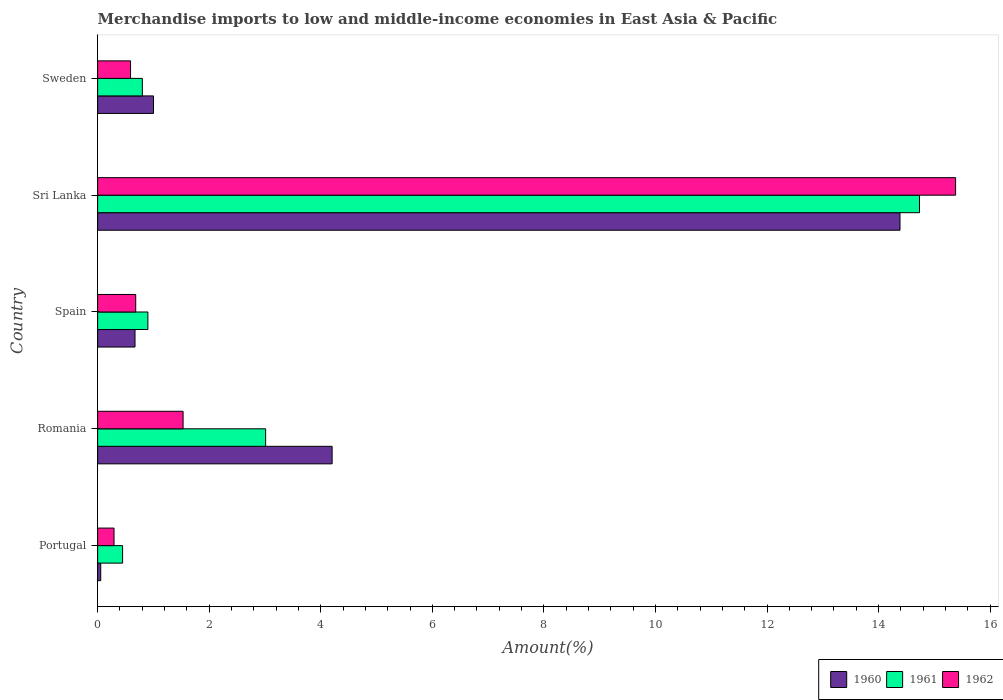How many different coloured bars are there?
Offer a terse response. 3. How many groups of bars are there?
Your answer should be compact. 5. How many bars are there on the 5th tick from the bottom?
Give a very brief answer. 3. What is the percentage of amount earned from merchandise imports in 1961 in Romania?
Offer a terse response. 3.01. Across all countries, what is the maximum percentage of amount earned from merchandise imports in 1961?
Offer a terse response. 14.73. Across all countries, what is the minimum percentage of amount earned from merchandise imports in 1961?
Provide a short and direct response. 0.45. In which country was the percentage of amount earned from merchandise imports in 1962 maximum?
Your answer should be compact. Sri Lanka. What is the total percentage of amount earned from merchandise imports in 1962 in the graph?
Ensure brevity in your answer.  18.48. What is the difference between the percentage of amount earned from merchandise imports in 1960 in Romania and that in Spain?
Provide a short and direct response. 3.53. What is the difference between the percentage of amount earned from merchandise imports in 1962 in Romania and the percentage of amount earned from merchandise imports in 1960 in Sri Lanka?
Your response must be concise. -12.85. What is the average percentage of amount earned from merchandise imports in 1960 per country?
Offer a very short reply. 4.06. What is the difference between the percentage of amount earned from merchandise imports in 1960 and percentage of amount earned from merchandise imports in 1962 in Sweden?
Offer a very short reply. 0.41. What is the ratio of the percentage of amount earned from merchandise imports in 1961 in Portugal to that in Romania?
Provide a succinct answer. 0.15. What is the difference between the highest and the second highest percentage of amount earned from merchandise imports in 1961?
Make the answer very short. 11.72. What is the difference between the highest and the lowest percentage of amount earned from merchandise imports in 1960?
Your answer should be compact. 14.33. In how many countries, is the percentage of amount earned from merchandise imports in 1960 greater than the average percentage of amount earned from merchandise imports in 1960 taken over all countries?
Provide a succinct answer. 2. Is the sum of the percentage of amount earned from merchandise imports in 1961 in Portugal and Romania greater than the maximum percentage of amount earned from merchandise imports in 1960 across all countries?
Your response must be concise. No. How many countries are there in the graph?
Your answer should be compact. 5. What is the difference between two consecutive major ticks on the X-axis?
Your answer should be very brief. 2. How many legend labels are there?
Ensure brevity in your answer.  3. How are the legend labels stacked?
Provide a succinct answer. Horizontal. What is the title of the graph?
Provide a short and direct response. Merchandise imports to low and middle-income economies in East Asia & Pacific. Does "2004" appear as one of the legend labels in the graph?
Make the answer very short. No. What is the label or title of the X-axis?
Give a very brief answer. Amount(%). What is the Amount(%) of 1960 in Portugal?
Your answer should be very brief. 0.06. What is the Amount(%) of 1961 in Portugal?
Offer a very short reply. 0.45. What is the Amount(%) in 1962 in Portugal?
Offer a terse response. 0.29. What is the Amount(%) of 1960 in Romania?
Give a very brief answer. 4.2. What is the Amount(%) of 1961 in Romania?
Offer a terse response. 3.01. What is the Amount(%) in 1962 in Romania?
Provide a short and direct response. 1.53. What is the Amount(%) of 1960 in Spain?
Your response must be concise. 0.67. What is the Amount(%) in 1961 in Spain?
Offer a very short reply. 0.9. What is the Amount(%) of 1962 in Spain?
Provide a succinct answer. 0.68. What is the Amount(%) of 1960 in Sri Lanka?
Give a very brief answer. 14.38. What is the Amount(%) of 1961 in Sri Lanka?
Your answer should be compact. 14.73. What is the Amount(%) of 1962 in Sri Lanka?
Provide a succinct answer. 15.38. What is the Amount(%) of 1960 in Sweden?
Provide a succinct answer. 1. What is the Amount(%) in 1961 in Sweden?
Provide a short and direct response. 0.8. What is the Amount(%) of 1962 in Sweden?
Provide a succinct answer. 0.59. Across all countries, what is the maximum Amount(%) of 1960?
Offer a terse response. 14.38. Across all countries, what is the maximum Amount(%) in 1961?
Provide a short and direct response. 14.73. Across all countries, what is the maximum Amount(%) in 1962?
Your response must be concise. 15.38. Across all countries, what is the minimum Amount(%) of 1960?
Ensure brevity in your answer.  0.06. Across all countries, what is the minimum Amount(%) in 1961?
Your response must be concise. 0.45. Across all countries, what is the minimum Amount(%) in 1962?
Your answer should be very brief. 0.29. What is the total Amount(%) in 1960 in the graph?
Keep it short and to the point. 20.31. What is the total Amount(%) in 1961 in the graph?
Your response must be concise. 19.89. What is the total Amount(%) in 1962 in the graph?
Keep it short and to the point. 18.48. What is the difference between the Amount(%) in 1960 in Portugal and that in Romania?
Your answer should be very brief. -4.15. What is the difference between the Amount(%) in 1961 in Portugal and that in Romania?
Make the answer very short. -2.56. What is the difference between the Amount(%) in 1962 in Portugal and that in Romania?
Ensure brevity in your answer.  -1.24. What is the difference between the Amount(%) of 1960 in Portugal and that in Spain?
Your answer should be compact. -0.61. What is the difference between the Amount(%) in 1961 in Portugal and that in Spain?
Provide a succinct answer. -0.45. What is the difference between the Amount(%) in 1962 in Portugal and that in Spain?
Ensure brevity in your answer.  -0.39. What is the difference between the Amount(%) of 1960 in Portugal and that in Sri Lanka?
Your answer should be compact. -14.33. What is the difference between the Amount(%) in 1961 in Portugal and that in Sri Lanka?
Make the answer very short. -14.29. What is the difference between the Amount(%) of 1962 in Portugal and that in Sri Lanka?
Ensure brevity in your answer.  -15.09. What is the difference between the Amount(%) of 1960 in Portugal and that in Sweden?
Keep it short and to the point. -0.95. What is the difference between the Amount(%) in 1961 in Portugal and that in Sweden?
Make the answer very short. -0.35. What is the difference between the Amount(%) in 1962 in Portugal and that in Sweden?
Offer a terse response. -0.3. What is the difference between the Amount(%) in 1960 in Romania and that in Spain?
Keep it short and to the point. 3.53. What is the difference between the Amount(%) of 1961 in Romania and that in Spain?
Your answer should be compact. 2.11. What is the difference between the Amount(%) of 1962 in Romania and that in Spain?
Your answer should be very brief. 0.85. What is the difference between the Amount(%) in 1960 in Romania and that in Sri Lanka?
Provide a short and direct response. -10.18. What is the difference between the Amount(%) in 1961 in Romania and that in Sri Lanka?
Provide a succinct answer. -11.72. What is the difference between the Amount(%) of 1962 in Romania and that in Sri Lanka?
Your answer should be compact. -13.85. What is the difference between the Amount(%) of 1960 in Romania and that in Sweden?
Provide a short and direct response. 3.2. What is the difference between the Amount(%) of 1961 in Romania and that in Sweden?
Your answer should be very brief. 2.21. What is the difference between the Amount(%) in 1962 in Romania and that in Sweden?
Give a very brief answer. 0.94. What is the difference between the Amount(%) in 1960 in Spain and that in Sri Lanka?
Your response must be concise. -13.71. What is the difference between the Amount(%) in 1961 in Spain and that in Sri Lanka?
Make the answer very short. -13.83. What is the difference between the Amount(%) in 1962 in Spain and that in Sri Lanka?
Keep it short and to the point. -14.7. What is the difference between the Amount(%) in 1960 in Spain and that in Sweden?
Your response must be concise. -0.33. What is the difference between the Amount(%) in 1961 in Spain and that in Sweden?
Keep it short and to the point. 0.1. What is the difference between the Amount(%) of 1962 in Spain and that in Sweden?
Your answer should be compact. 0.09. What is the difference between the Amount(%) in 1960 in Sri Lanka and that in Sweden?
Keep it short and to the point. 13.38. What is the difference between the Amount(%) of 1961 in Sri Lanka and that in Sweden?
Provide a short and direct response. 13.93. What is the difference between the Amount(%) in 1962 in Sri Lanka and that in Sweden?
Provide a succinct answer. 14.79. What is the difference between the Amount(%) of 1960 in Portugal and the Amount(%) of 1961 in Romania?
Offer a terse response. -2.96. What is the difference between the Amount(%) of 1960 in Portugal and the Amount(%) of 1962 in Romania?
Provide a short and direct response. -1.48. What is the difference between the Amount(%) in 1961 in Portugal and the Amount(%) in 1962 in Romania?
Offer a terse response. -1.08. What is the difference between the Amount(%) of 1960 in Portugal and the Amount(%) of 1961 in Spain?
Provide a succinct answer. -0.85. What is the difference between the Amount(%) in 1960 in Portugal and the Amount(%) in 1962 in Spain?
Your response must be concise. -0.63. What is the difference between the Amount(%) in 1961 in Portugal and the Amount(%) in 1962 in Spain?
Offer a very short reply. -0.24. What is the difference between the Amount(%) of 1960 in Portugal and the Amount(%) of 1961 in Sri Lanka?
Offer a terse response. -14.68. What is the difference between the Amount(%) in 1960 in Portugal and the Amount(%) in 1962 in Sri Lanka?
Your answer should be very brief. -15.32. What is the difference between the Amount(%) in 1961 in Portugal and the Amount(%) in 1962 in Sri Lanka?
Offer a terse response. -14.93. What is the difference between the Amount(%) of 1960 in Portugal and the Amount(%) of 1961 in Sweden?
Keep it short and to the point. -0.75. What is the difference between the Amount(%) in 1960 in Portugal and the Amount(%) in 1962 in Sweden?
Your answer should be very brief. -0.53. What is the difference between the Amount(%) of 1961 in Portugal and the Amount(%) of 1962 in Sweden?
Ensure brevity in your answer.  -0.14. What is the difference between the Amount(%) in 1960 in Romania and the Amount(%) in 1961 in Spain?
Provide a succinct answer. 3.3. What is the difference between the Amount(%) of 1960 in Romania and the Amount(%) of 1962 in Spain?
Offer a terse response. 3.52. What is the difference between the Amount(%) of 1961 in Romania and the Amount(%) of 1962 in Spain?
Offer a very short reply. 2.33. What is the difference between the Amount(%) in 1960 in Romania and the Amount(%) in 1961 in Sri Lanka?
Provide a succinct answer. -10.53. What is the difference between the Amount(%) of 1960 in Romania and the Amount(%) of 1962 in Sri Lanka?
Offer a terse response. -11.18. What is the difference between the Amount(%) in 1961 in Romania and the Amount(%) in 1962 in Sri Lanka?
Keep it short and to the point. -12.37. What is the difference between the Amount(%) of 1960 in Romania and the Amount(%) of 1961 in Sweden?
Keep it short and to the point. 3.4. What is the difference between the Amount(%) of 1960 in Romania and the Amount(%) of 1962 in Sweden?
Keep it short and to the point. 3.61. What is the difference between the Amount(%) in 1961 in Romania and the Amount(%) in 1962 in Sweden?
Provide a succinct answer. 2.42. What is the difference between the Amount(%) of 1960 in Spain and the Amount(%) of 1961 in Sri Lanka?
Provide a short and direct response. -14.06. What is the difference between the Amount(%) of 1960 in Spain and the Amount(%) of 1962 in Sri Lanka?
Offer a very short reply. -14.71. What is the difference between the Amount(%) of 1961 in Spain and the Amount(%) of 1962 in Sri Lanka?
Ensure brevity in your answer.  -14.48. What is the difference between the Amount(%) in 1960 in Spain and the Amount(%) in 1961 in Sweden?
Provide a succinct answer. -0.13. What is the difference between the Amount(%) of 1960 in Spain and the Amount(%) of 1962 in Sweden?
Offer a very short reply. 0.08. What is the difference between the Amount(%) of 1961 in Spain and the Amount(%) of 1962 in Sweden?
Your response must be concise. 0.31. What is the difference between the Amount(%) in 1960 in Sri Lanka and the Amount(%) in 1961 in Sweden?
Offer a very short reply. 13.58. What is the difference between the Amount(%) in 1960 in Sri Lanka and the Amount(%) in 1962 in Sweden?
Offer a very short reply. 13.79. What is the difference between the Amount(%) of 1961 in Sri Lanka and the Amount(%) of 1962 in Sweden?
Give a very brief answer. 14.14. What is the average Amount(%) in 1960 per country?
Provide a short and direct response. 4.06. What is the average Amount(%) in 1961 per country?
Your answer should be compact. 3.98. What is the average Amount(%) of 1962 per country?
Your answer should be very brief. 3.7. What is the difference between the Amount(%) in 1960 and Amount(%) in 1961 in Portugal?
Your response must be concise. -0.39. What is the difference between the Amount(%) of 1960 and Amount(%) of 1962 in Portugal?
Your response must be concise. -0.24. What is the difference between the Amount(%) of 1961 and Amount(%) of 1962 in Portugal?
Give a very brief answer. 0.15. What is the difference between the Amount(%) in 1960 and Amount(%) in 1961 in Romania?
Provide a succinct answer. 1.19. What is the difference between the Amount(%) in 1960 and Amount(%) in 1962 in Romania?
Your response must be concise. 2.67. What is the difference between the Amount(%) in 1961 and Amount(%) in 1962 in Romania?
Your response must be concise. 1.48. What is the difference between the Amount(%) in 1960 and Amount(%) in 1961 in Spain?
Your response must be concise. -0.23. What is the difference between the Amount(%) in 1960 and Amount(%) in 1962 in Spain?
Offer a terse response. -0.01. What is the difference between the Amount(%) in 1961 and Amount(%) in 1962 in Spain?
Provide a succinct answer. 0.22. What is the difference between the Amount(%) of 1960 and Amount(%) of 1961 in Sri Lanka?
Provide a short and direct response. -0.35. What is the difference between the Amount(%) of 1960 and Amount(%) of 1962 in Sri Lanka?
Your answer should be very brief. -1. What is the difference between the Amount(%) of 1961 and Amount(%) of 1962 in Sri Lanka?
Your answer should be compact. -0.65. What is the difference between the Amount(%) of 1960 and Amount(%) of 1961 in Sweden?
Offer a terse response. 0.2. What is the difference between the Amount(%) in 1960 and Amount(%) in 1962 in Sweden?
Offer a terse response. 0.41. What is the difference between the Amount(%) of 1961 and Amount(%) of 1962 in Sweden?
Offer a very short reply. 0.21. What is the ratio of the Amount(%) in 1960 in Portugal to that in Romania?
Your answer should be compact. 0.01. What is the ratio of the Amount(%) of 1961 in Portugal to that in Romania?
Provide a short and direct response. 0.15. What is the ratio of the Amount(%) in 1962 in Portugal to that in Romania?
Provide a short and direct response. 0.19. What is the ratio of the Amount(%) of 1960 in Portugal to that in Spain?
Your answer should be very brief. 0.08. What is the ratio of the Amount(%) of 1961 in Portugal to that in Spain?
Keep it short and to the point. 0.5. What is the ratio of the Amount(%) in 1962 in Portugal to that in Spain?
Keep it short and to the point. 0.43. What is the ratio of the Amount(%) in 1960 in Portugal to that in Sri Lanka?
Make the answer very short. 0. What is the ratio of the Amount(%) of 1961 in Portugal to that in Sri Lanka?
Offer a terse response. 0.03. What is the ratio of the Amount(%) of 1962 in Portugal to that in Sri Lanka?
Make the answer very short. 0.02. What is the ratio of the Amount(%) of 1960 in Portugal to that in Sweden?
Make the answer very short. 0.06. What is the ratio of the Amount(%) in 1961 in Portugal to that in Sweden?
Keep it short and to the point. 0.56. What is the ratio of the Amount(%) in 1962 in Portugal to that in Sweden?
Make the answer very short. 0.5. What is the ratio of the Amount(%) of 1960 in Romania to that in Spain?
Keep it short and to the point. 6.27. What is the ratio of the Amount(%) of 1961 in Romania to that in Spain?
Ensure brevity in your answer.  3.34. What is the ratio of the Amount(%) in 1962 in Romania to that in Spain?
Make the answer very short. 2.24. What is the ratio of the Amount(%) of 1960 in Romania to that in Sri Lanka?
Your answer should be compact. 0.29. What is the ratio of the Amount(%) in 1961 in Romania to that in Sri Lanka?
Your answer should be very brief. 0.2. What is the ratio of the Amount(%) of 1962 in Romania to that in Sri Lanka?
Offer a terse response. 0.1. What is the ratio of the Amount(%) of 1960 in Romania to that in Sweden?
Your response must be concise. 4.2. What is the ratio of the Amount(%) in 1961 in Romania to that in Sweden?
Keep it short and to the point. 3.76. What is the ratio of the Amount(%) of 1962 in Romania to that in Sweden?
Keep it short and to the point. 2.6. What is the ratio of the Amount(%) in 1960 in Spain to that in Sri Lanka?
Your answer should be compact. 0.05. What is the ratio of the Amount(%) in 1961 in Spain to that in Sri Lanka?
Keep it short and to the point. 0.06. What is the ratio of the Amount(%) in 1962 in Spain to that in Sri Lanka?
Provide a succinct answer. 0.04. What is the ratio of the Amount(%) of 1960 in Spain to that in Sweden?
Offer a very short reply. 0.67. What is the ratio of the Amount(%) in 1961 in Spain to that in Sweden?
Ensure brevity in your answer.  1.12. What is the ratio of the Amount(%) in 1962 in Spain to that in Sweden?
Give a very brief answer. 1.16. What is the ratio of the Amount(%) of 1960 in Sri Lanka to that in Sweden?
Your response must be concise. 14.36. What is the ratio of the Amount(%) of 1961 in Sri Lanka to that in Sweden?
Ensure brevity in your answer.  18.38. What is the ratio of the Amount(%) in 1962 in Sri Lanka to that in Sweden?
Make the answer very short. 26.07. What is the difference between the highest and the second highest Amount(%) in 1960?
Your response must be concise. 10.18. What is the difference between the highest and the second highest Amount(%) in 1961?
Provide a succinct answer. 11.72. What is the difference between the highest and the second highest Amount(%) of 1962?
Offer a terse response. 13.85. What is the difference between the highest and the lowest Amount(%) in 1960?
Your answer should be very brief. 14.33. What is the difference between the highest and the lowest Amount(%) of 1961?
Ensure brevity in your answer.  14.29. What is the difference between the highest and the lowest Amount(%) in 1962?
Make the answer very short. 15.09. 